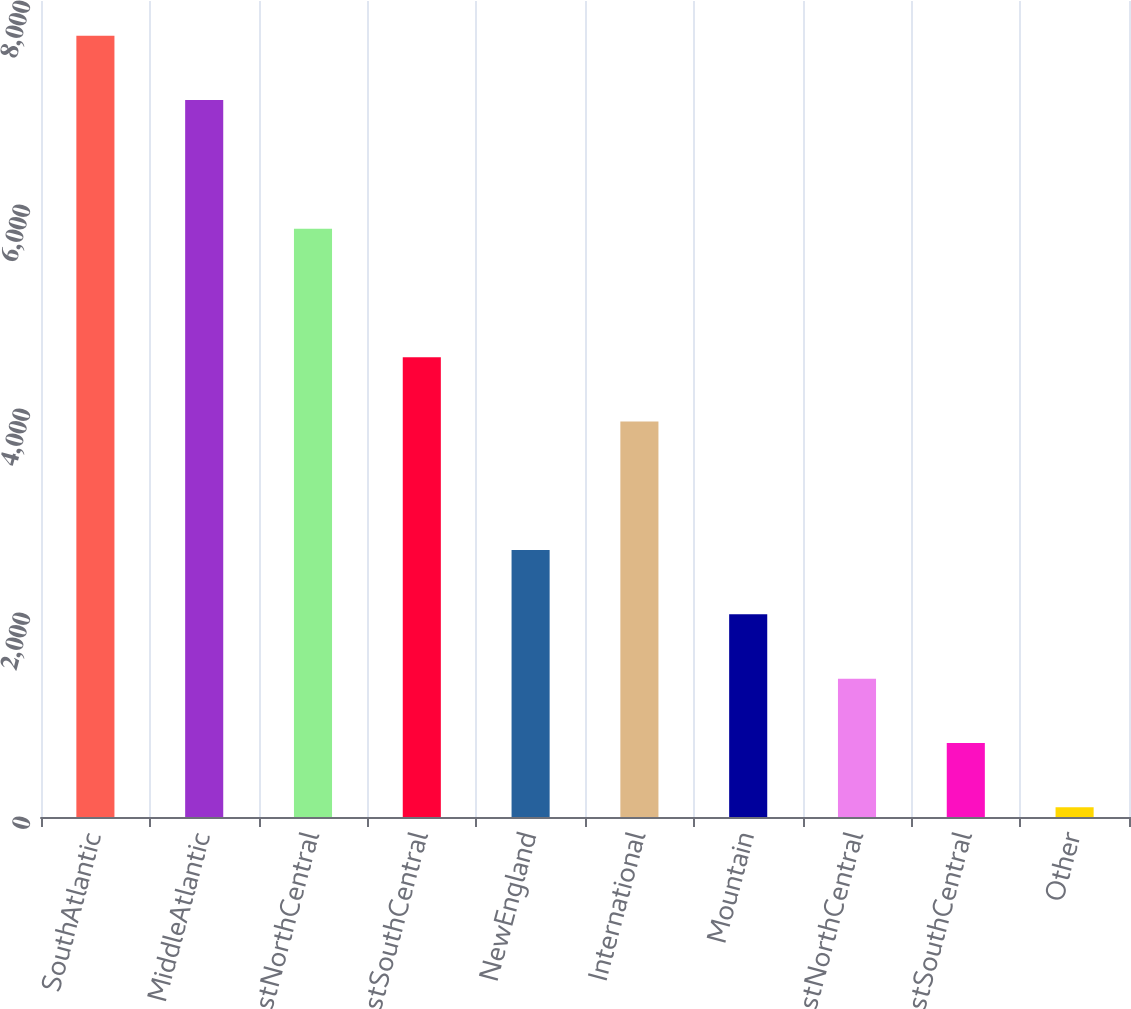Convert chart to OTSL. <chart><loc_0><loc_0><loc_500><loc_500><bar_chart><fcel>SouthAtlantic<fcel>MiddleAtlantic<fcel>EastNorthCentral<fcel>WestSouthCentral<fcel>NewEngland<fcel>International<fcel>Mountain<fcel>WestNorthCentral<fcel>EastSouthCentral<fcel>Other<nl><fcel>7658.4<fcel>7028.2<fcel>5767.8<fcel>4507.4<fcel>2616.8<fcel>3877.2<fcel>1986.6<fcel>1356.4<fcel>726.2<fcel>96<nl></chart> 